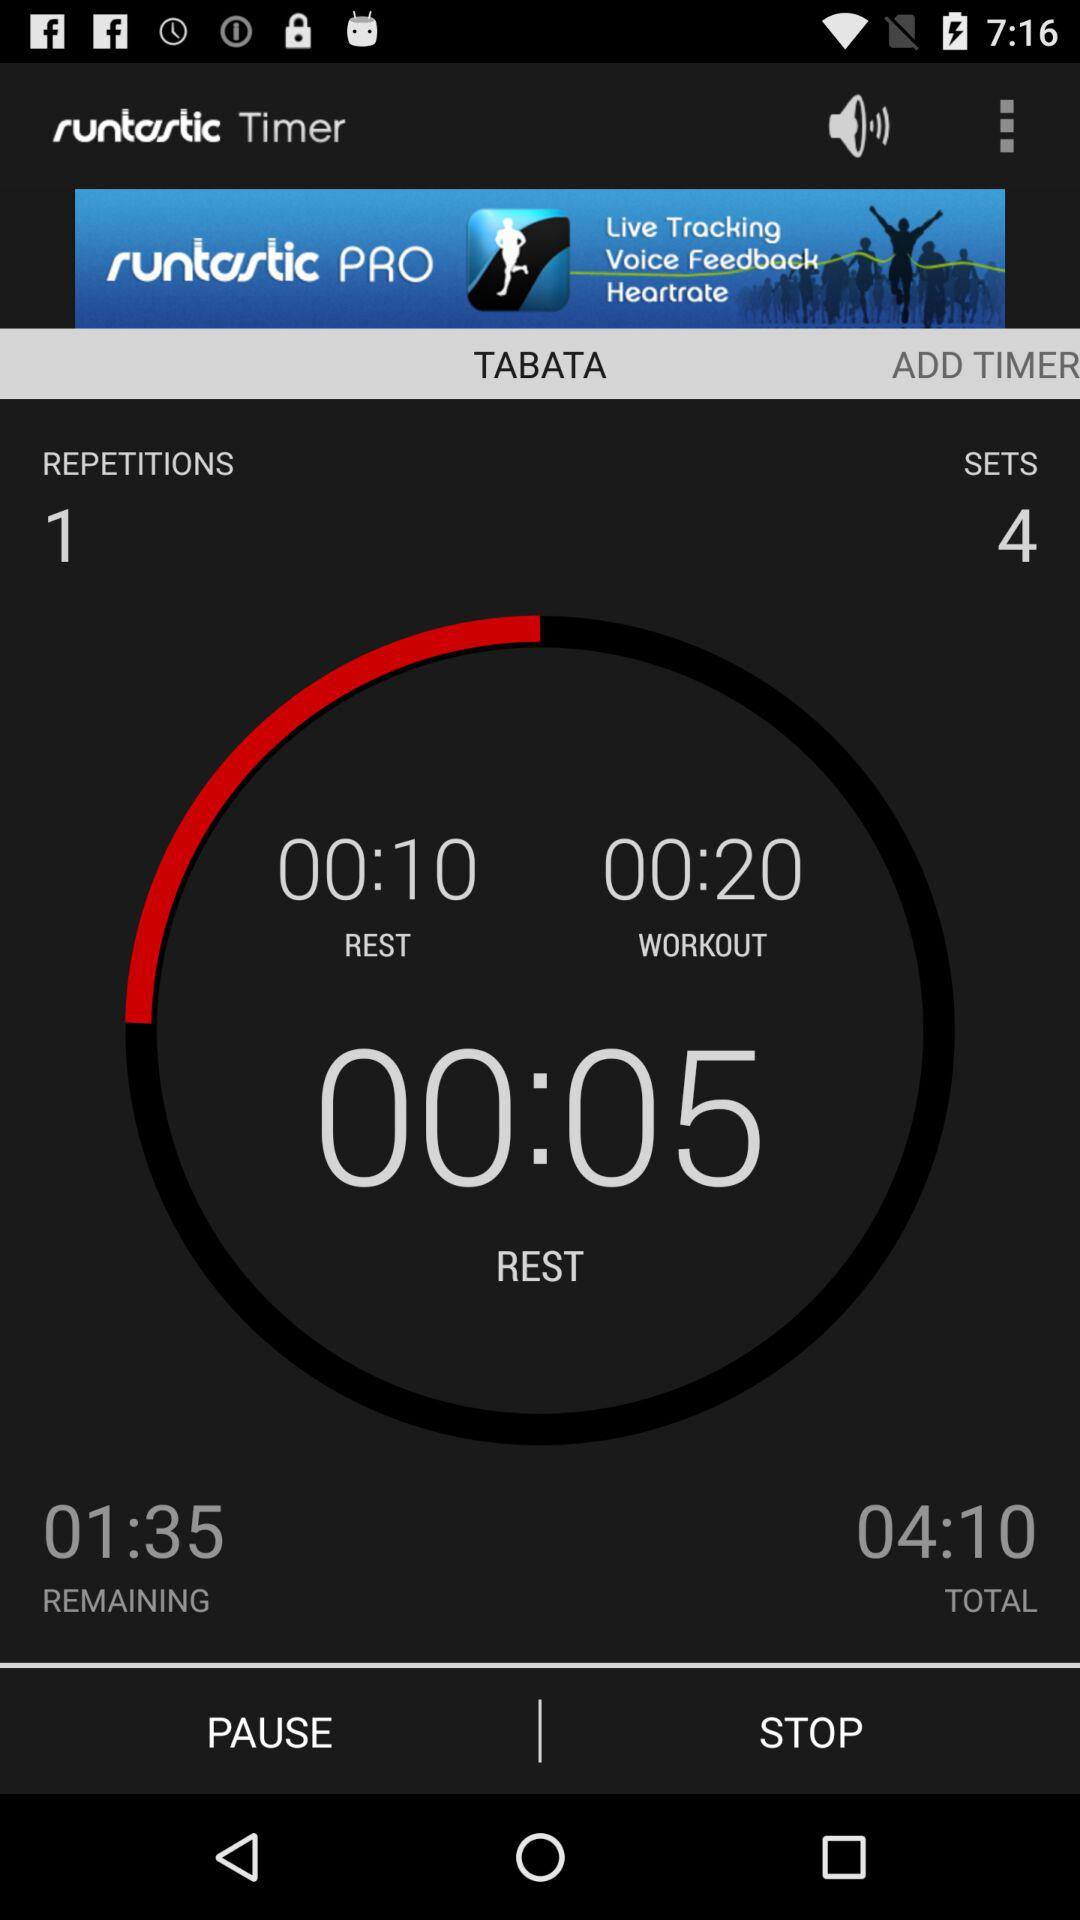What is the count of repetitions? The count of repetitions is 1. 